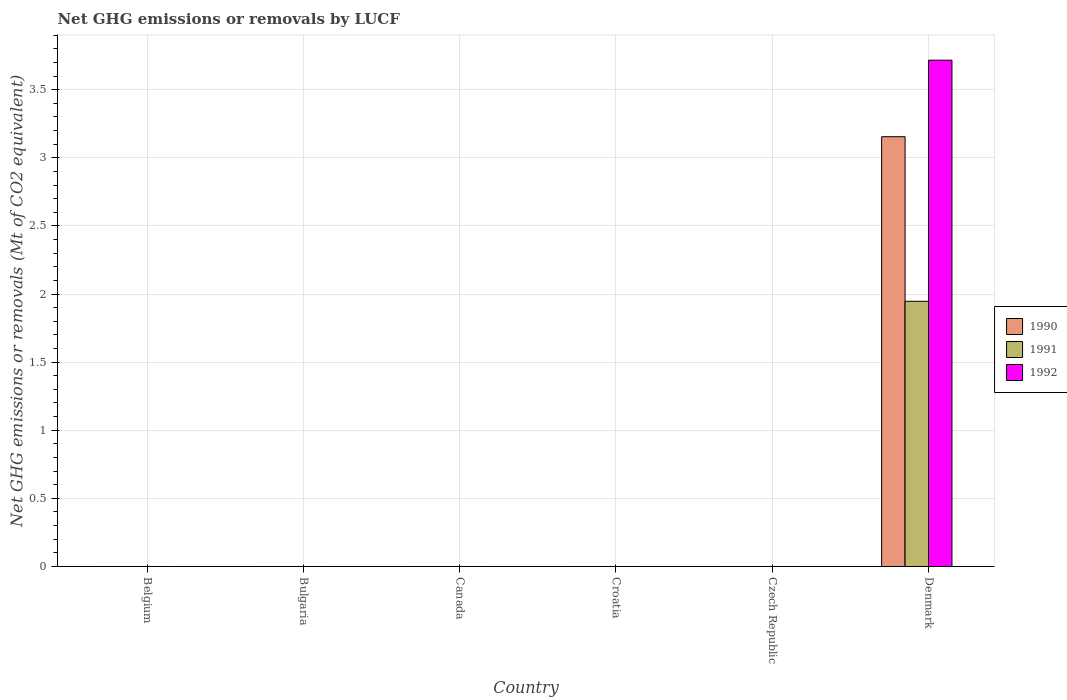Are the number of bars per tick equal to the number of legend labels?
Offer a terse response. No. Are the number of bars on each tick of the X-axis equal?
Your answer should be compact. No. How many bars are there on the 3rd tick from the left?
Give a very brief answer. 0. What is the label of the 2nd group of bars from the left?
Your answer should be compact. Bulgaria. What is the net GHG emissions or removals by LUCF in 1991 in Czech Republic?
Make the answer very short. 0. Across all countries, what is the maximum net GHG emissions or removals by LUCF in 1991?
Your answer should be compact. 1.95. What is the total net GHG emissions or removals by LUCF in 1991 in the graph?
Ensure brevity in your answer.  1.95. What is the difference between the net GHG emissions or removals by LUCF in 1992 in Belgium and the net GHG emissions or removals by LUCF in 1990 in Denmark?
Offer a very short reply. -3.15. What is the average net GHG emissions or removals by LUCF in 1992 per country?
Ensure brevity in your answer.  0.62. What is the difference between the net GHG emissions or removals by LUCF of/in 1990 and net GHG emissions or removals by LUCF of/in 1992 in Denmark?
Provide a short and direct response. -0.56. What is the difference between the highest and the lowest net GHG emissions or removals by LUCF in 1990?
Your answer should be compact. 3.15. In how many countries, is the net GHG emissions or removals by LUCF in 1991 greater than the average net GHG emissions or removals by LUCF in 1991 taken over all countries?
Give a very brief answer. 1. Is it the case that in every country, the sum of the net GHG emissions or removals by LUCF in 1992 and net GHG emissions or removals by LUCF in 1991 is greater than the net GHG emissions or removals by LUCF in 1990?
Your response must be concise. No. How many countries are there in the graph?
Your response must be concise. 6. What is the difference between two consecutive major ticks on the Y-axis?
Your response must be concise. 0.5. Does the graph contain grids?
Your answer should be compact. Yes. How many legend labels are there?
Offer a very short reply. 3. What is the title of the graph?
Ensure brevity in your answer.  Net GHG emissions or removals by LUCF. Does "2009" appear as one of the legend labels in the graph?
Keep it short and to the point. No. What is the label or title of the X-axis?
Your answer should be compact. Country. What is the label or title of the Y-axis?
Provide a succinct answer. Net GHG emissions or removals (Mt of CO2 equivalent). What is the Net GHG emissions or removals (Mt of CO2 equivalent) of 1992 in Belgium?
Make the answer very short. 0. What is the Net GHG emissions or removals (Mt of CO2 equivalent) in 1990 in Bulgaria?
Your answer should be very brief. 0. What is the Net GHG emissions or removals (Mt of CO2 equivalent) of 1992 in Bulgaria?
Offer a terse response. 0. What is the Net GHG emissions or removals (Mt of CO2 equivalent) in 1991 in Canada?
Offer a very short reply. 0. What is the Net GHG emissions or removals (Mt of CO2 equivalent) in 1992 in Canada?
Your response must be concise. 0. What is the Net GHG emissions or removals (Mt of CO2 equivalent) in 1992 in Croatia?
Your response must be concise. 0. What is the Net GHG emissions or removals (Mt of CO2 equivalent) of 1990 in Czech Republic?
Provide a succinct answer. 0. What is the Net GHG emissions or removals (Mt of CO2 equivalent) in 1991 in Czech Republic?
Offer a very short reply. 0. What is the Net GHG emissions or removals (Mt of CO2 equivalent) in 1990 in Denmark?
Offer a very short reply. 3.15. What is the Net GHG emissions or removals (Mt of CO2 equivalent) in 1991 in Denmark?
Offer a terse response. 1.95. What is the Net GHG emissions or removals (Mt of CO2 equivalent) in 1992 in Denmark?
Give a very brief answer. 3.72. Across all countries, what is the maximum Net GHG emissions or removals (Mt of CO2 equivalent) of 1990?
Make the answer very short. 3.15. Across all countries, what is the maximum Net GHG emissions or removals (Mt of CO2 equivalent) in 1991?
Provide a succinct answer. 1.95. Across all countries, what is the maximum Net GHG emissions or removals (Mt of CO2 equivalent) in 1992?
Your answer should be compact. 3.72. Across all countries, what is the minimum Net GHG emissions or removals (Mt of CO2 equivalent) in 1990?
Your answer should be compact. 0. Across all countries, what is the minimum Net GHG emissions or removals (Mt of CO2 equivalent) of 1992?
Offer a terse response. 0. What is the total Net GHG emissions or removals (Mt of CO2 equivalent) of 1990 in the graph?
Offer a terse response. 3.15. What is the total Net GHG emissions or removals (Mt of CO2 equivalent) of 1991 in the graph?
Provide a succinct answer. 1.95. What is the total Net GHG emissions or removals (Mt of CO2 equivalent) in 1992 in the graph?
Keep it short and to the point. 3.72. What is the average Net GHG emissions or removals (Mt of CO2 equivalent) of 1990 per country?
Offer a terse response. 0.53. What is the average Net GHG emissions or removals (Mt of CO2 equivalent) in 1991 per country?
Your answer should be very brief. 0.32. What is the average Net GHG emissions or removals (Mt of CO2 equivalent) in 1992 per country?
Provide a short and direct response. 0.62. What is the difference between the Net GHG emissions or removals (Mt of CO2 equivalent) of 1990 and Net GHG emissions or removals (Mt of CO2 equivalent) of 1991 in Denmark?
Keep it short and to the point. 1.21. What is the difference between the Net GHG emissions or removals (Mt of CO2 equivalent) in 1990 and Net GHG emissions or removals (Mt of CO2 equivalent) in 1992 in Denmark?
Offer a very short reply. -0.56. What is the difference between the Net GHG emissions or removals (Mt of CO2 equivalent) of 1991 and Net GHG emissions or removals (Mt of CO2 equivalent) of 1992 in Denmark?
Ensure brevity in your answer.  -1.77. What is the difference between the highest and the lowest Net GHG emissions or removals (Mt of CO2 equivalent) of 1990?
Provide a short and direct response. 3.15. What is the difference between the highest and the lowest Net GHG emissions or removals (Mt of CO2 equivalent) in 1991?
Your answer should be compact. 1.95. What is the difference between the highest and the lowest Net GHG emissions or removals (Mt of CO2 equivalent) in 1992?
Make the answer very short. 3.72. 